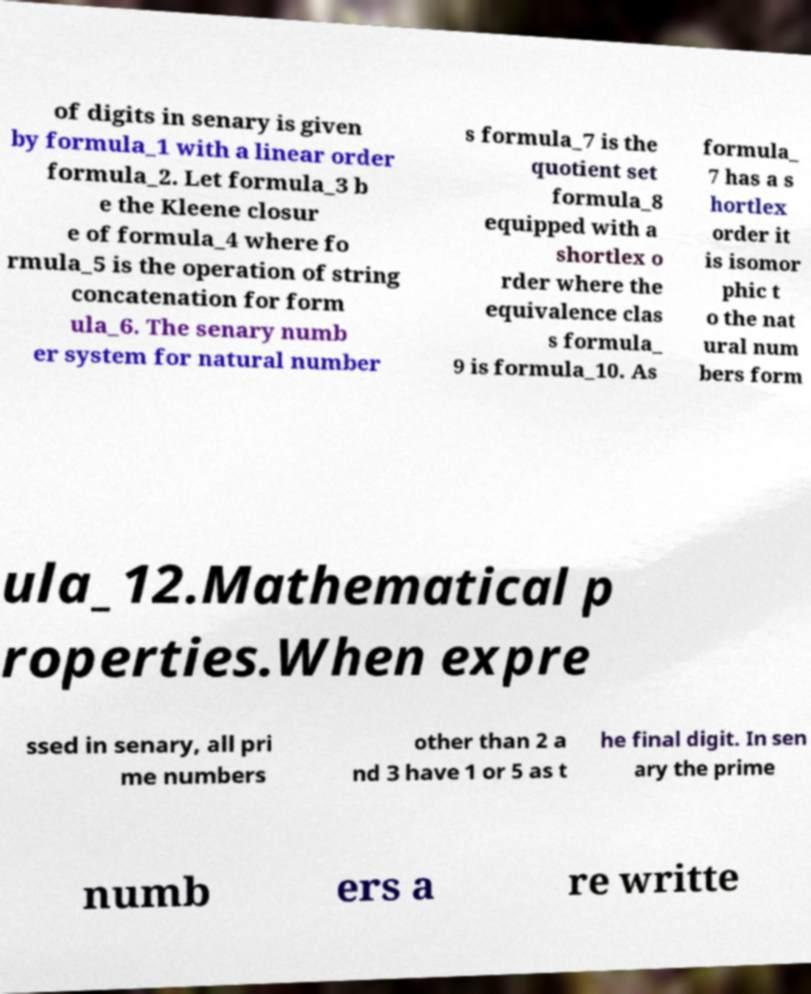Can you accurately transcribe the text from the provided image for me? of digits in senary is given by formula_1 with a linear order formula_2. Let formula_3 b e the Kleene closur e of formula_4 where fo rmula_5 is the operation of string concatenation for form ula_6. The senary numb er system for natural number s formula_7 is the quotient set formula_8 equipped with a shortlex o rder where the equivalence clas s formula_ 9 is formula_10. As formula_ 7 has a s hortlex order it is isomor phic t o the nat ural num bers form ula_12.Mathematical p roperties.When expre ssed in senary, all pri me numbers other than 2 a nd 3 have 1 or 5 as t he final digit. In sen ary the prime numb ers a re writte 